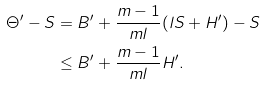<formula> <loc_0><loc_0><loc_500><loc_500>\Theta ^ { \prime } - S & = B ^ { \prime } + \frac { m - 1 } { m l } ( l S + H ^ { \prime } ) - S \\ & \leq B ^ { \prime } + \frac { m - 1 } { m l } H ^ { \prime } . \\</formula> 